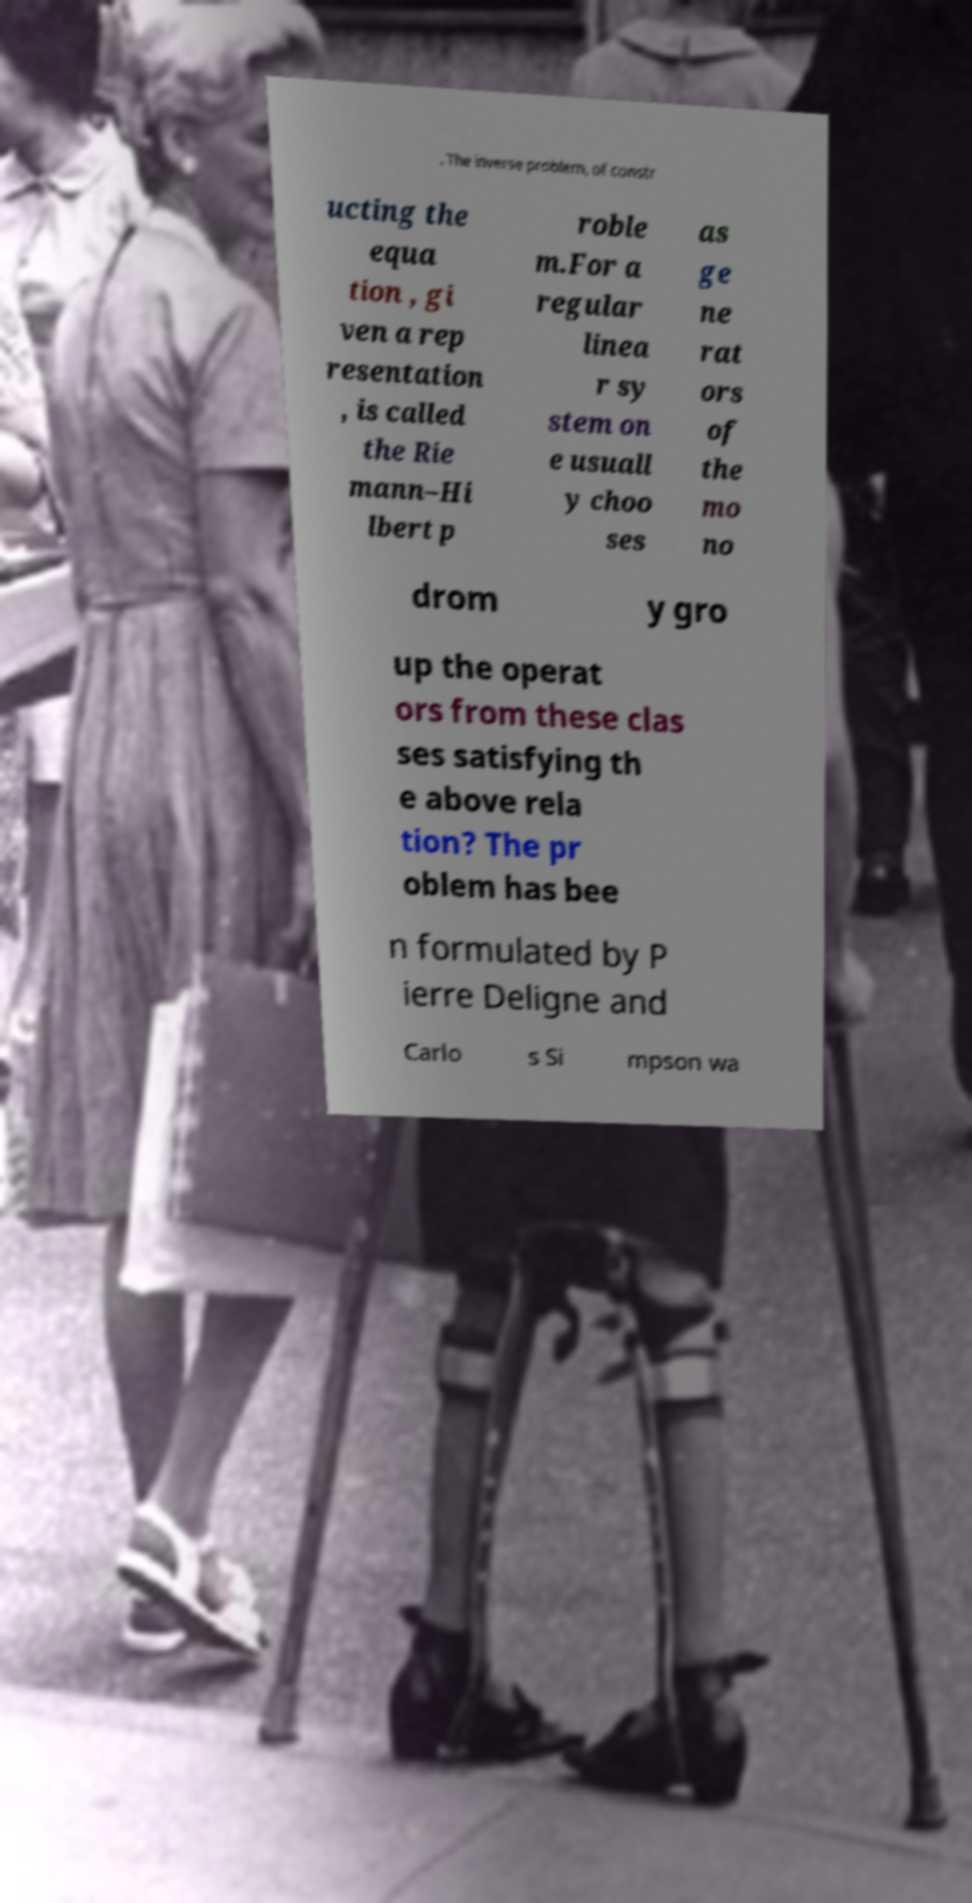What messages or text are displayed in this image? I need them in a readable, typed format. . The inverse problem, of constr ucting the equa tion , gi ven a rep resentation , is called the Rie mann–Hi lbert p roble m.For a regular linea r sy stem on e usuall y choo ses as ge ne rat ors of the mo no drom y gro up the operat ors from these clas ses satisfying th e above rela tion? The pr oblem has bee n formulated by P ierre Deligne and Carlo s Si mpson wa 